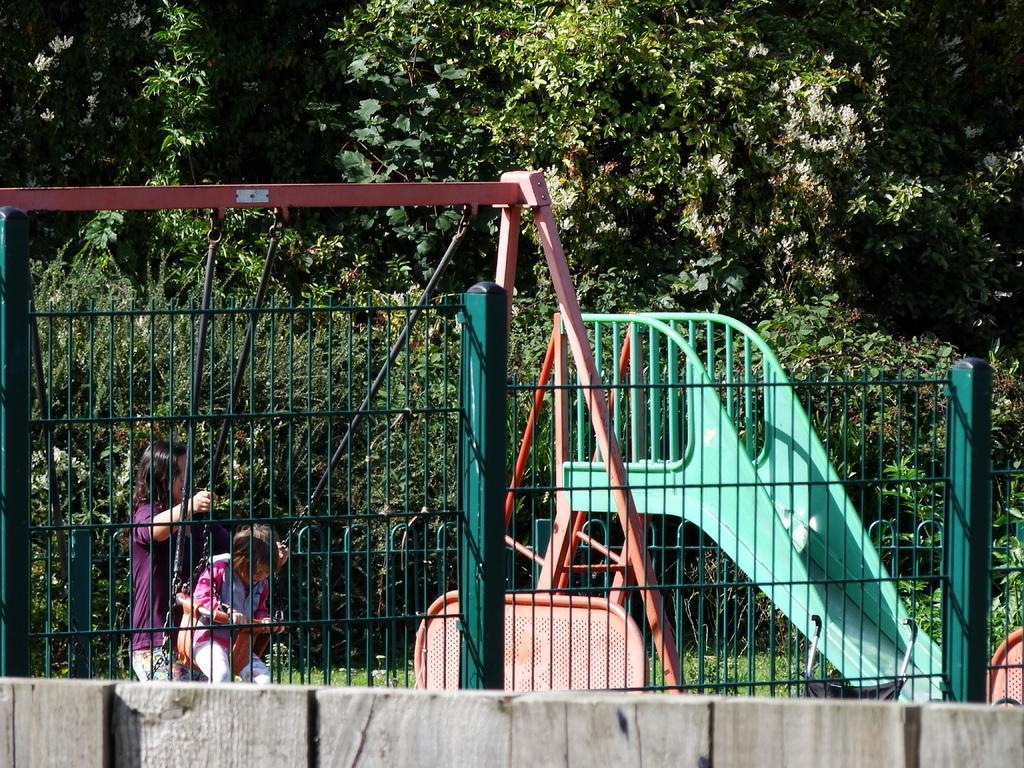Please provide a concise description of this image. In this image, we can see a fencing. Two childrens are playing swing. Here there is a slider. Background there are few plants, grass and trees. 